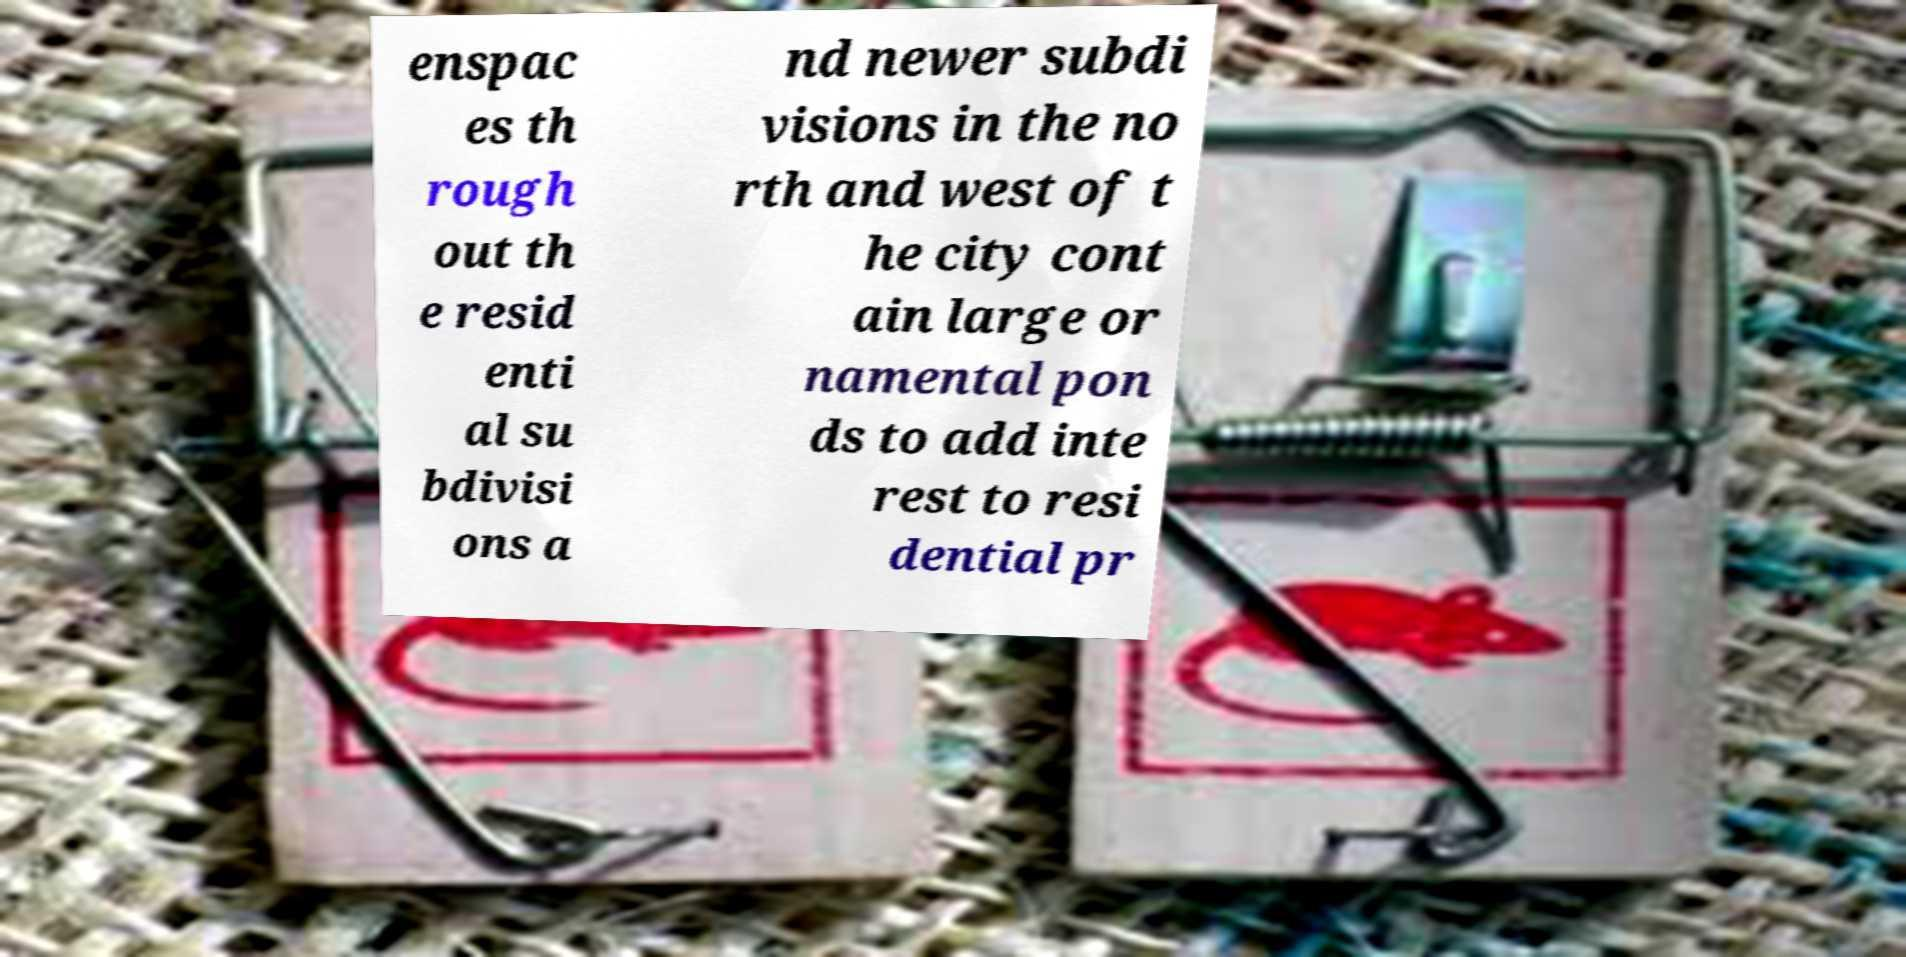Can you accurately transcribe the text from the provided image for me? enspac es th rough out th e resid enti al su bdivisi ons a nd newer subdi visions in the no rth and west of t he city cont ain large or namental pon ds to add inte rest to resi dential pr 